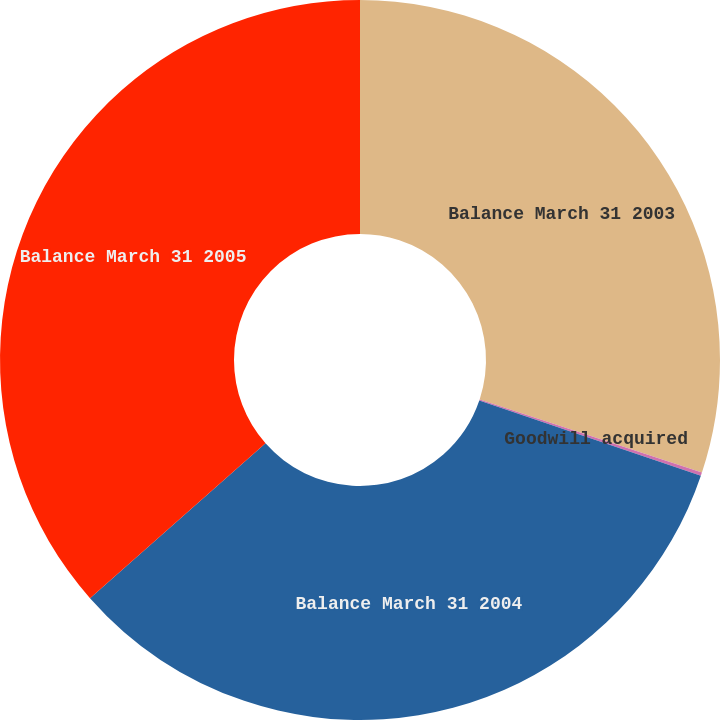<chart> <loc_0><loc_0><loc_500><loc_500><pie_chart><fcel>Balance March 31 2003<fcel>Goodwill acquired<fcel>Balance March 31 2004<fcel>Balance March 31 2005<nl><fcel>30.06%<fcel>0.15%<fcel>33.28%<fcel>36.5%<nl></chart> 